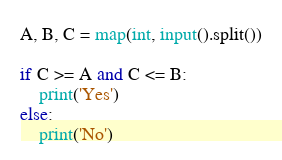Convert code to text. <code><loc_0><loc_0><loc_500><loc_500><_Python_>A, B, C = map(int, input().split())

if C >= A and C <= B:
	print('Yes')
else:
	print('No')</code> 